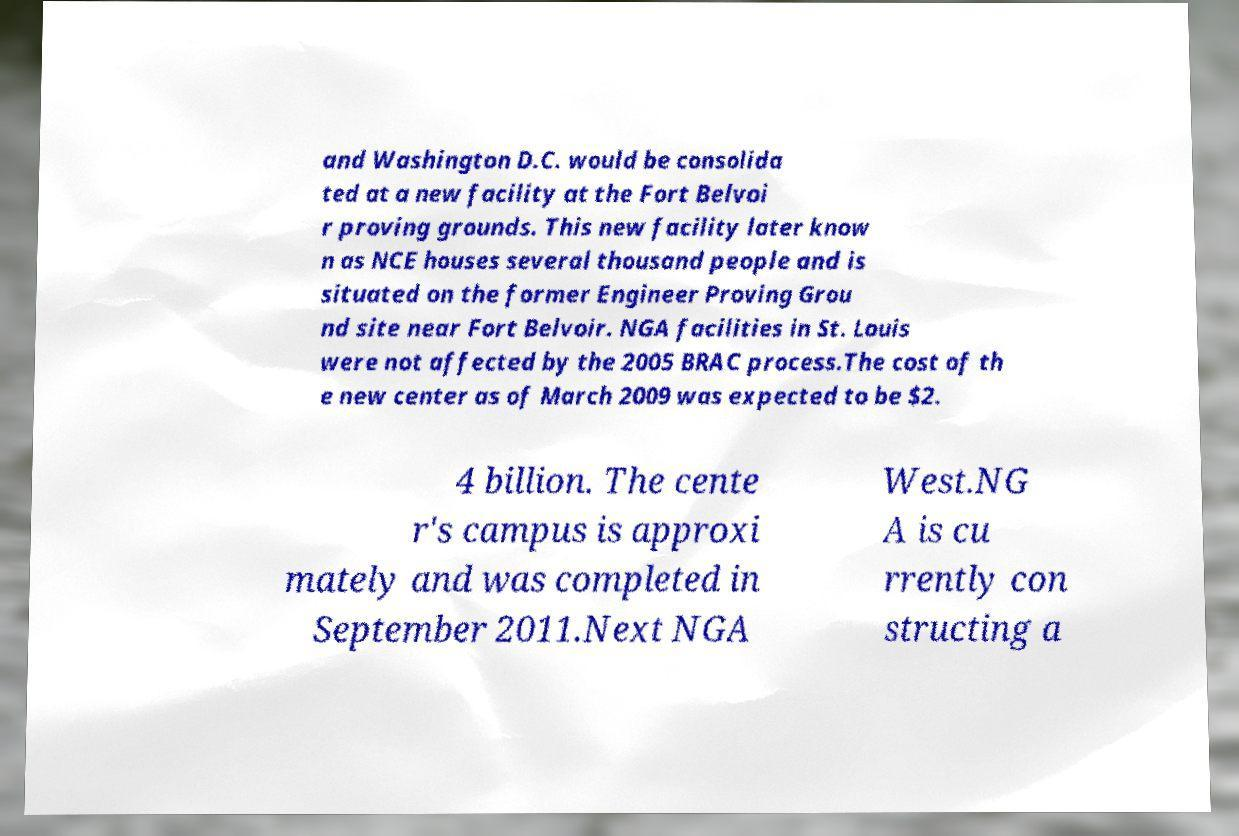There's text embedded in this image that I need extracted. Can you transcribe it verbatim? and Washington D.C. would be consolida ted at a new facility at the Fort Belvoi r proving grounds. This new facility later know n as NCE houses several thousand people and is situated on the former Engineer Proving Grou nd site near Fort Belvoir. NGA facilities in St. Louis were not affected by the 2005 BRAC process.The cost of th e new center as of March 2009 was expected to be $2. 4 billion. The cente r's campus is approxi mately and was completed in September 2011.Next NGA West.NG A is cu rrently con structing a 